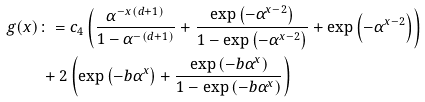Convert formula to latex. <formula><loc_0><loc_0><loc_500><loc_500>g ( x ) & \colon = c _ { 4 } \left ( \frac { \alpha ^ { - x ( d + 1 ) } } { 1 - \alpha ^ { - ( d + 1 ) } } + \frac { \exp \left ( - \alpha ^ { x - 2 } \right ) } { 1 - \exp \left ( - \alpha ^ { x - 2 } \right ) } + \exp \left ( - \alpha ^ { x - 2 } \right ) \right ) \\ & \, + 2 \left ( \exp \left ( - b \alpha ^ { x } \right ) + \frac { \exp \left ( - b \alpha ^ { x } \right ) } { 1 - \exp \left ( - b \alpha ^ { x } \right ) } \right )</formula> 